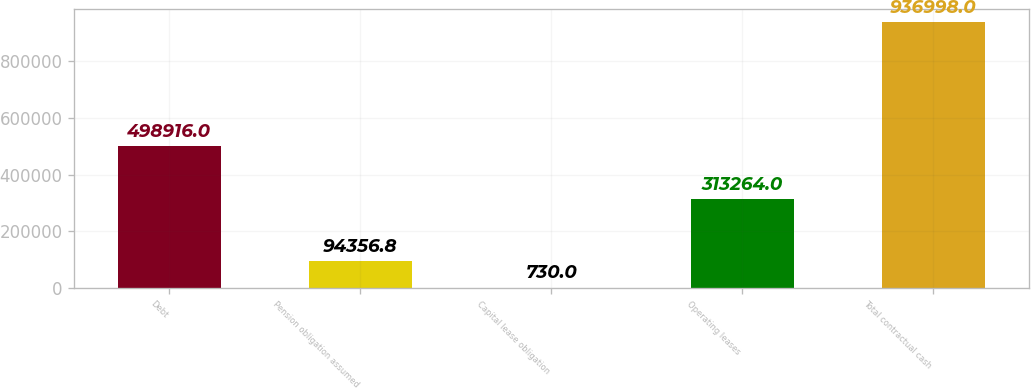Convert chart. <chart><loc_0><loc_0><loc_500><loc_500><bar_chart><fcel>Debt<fcel>Pension obligation assumed<fcel>Capital lease obligation<fcel>Operating leases<fcel>Total contractual cash<nl><fcel>498916<fcel>94356.8<fcel>730<fcel>313264<fcel>936998<nl></chart> 